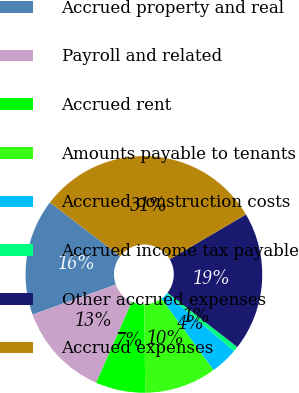Convert chart to OTSL. <chart><loc_0><loc_0><loc_500><loc_500><pie_chart><fcel>Accrued property and real<fcel>Payroll and related<fcel>Accrued rent<fcel>Amounts payable to tenants<fcel>Accrued construction costs<fcel>Accrued income tax payable<fcel>Other accrued expenses<fcel>Accrued expenses<nl><fcel>15.92%<fcel>12.88%<fcel>6.79%<fcel>9.84%<fcel>3.75%<fcel>0.71%<fcel>18.97%<fcel>31.14%<nl></chart> 